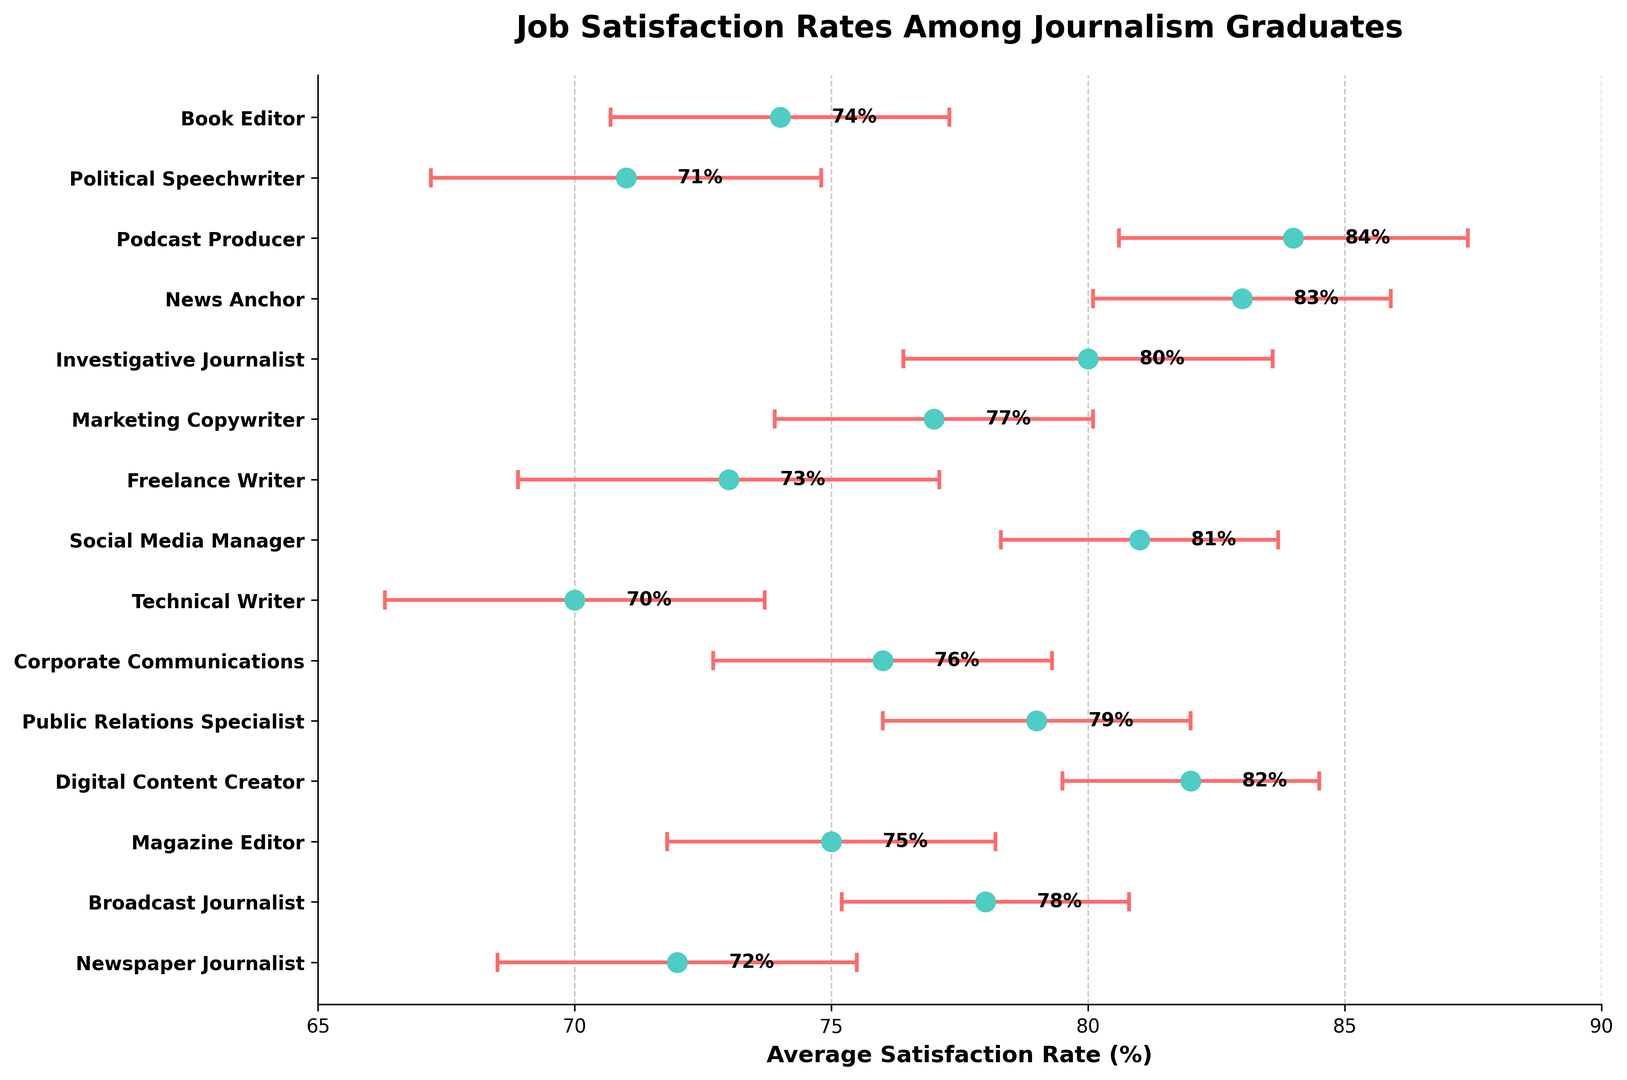Which career path has the highest job satisfaction rate? The plotted figure shows different career paths and their associated satisfaction rates. By visually identifying the highest point on the x-axis, we see that the Podcast Producer has the highest satisfaction rate, as represented by '84%'.
Answer: Podcast Producer Which career path has the lowest job satisfaction rate? By looking for the smallest point on the x-axis in the figure, we find that the Technical Writer has the lowest satisfaction rate at '70%'.
Answer: Technical Writer How does the job satisfaction rate of Public Relations Specialists compare to that of Investigative Journalists? Public Relations Specialists have a satisfaction rate of 79%, whereas Investigative Journalists have a satisfaction rate of 80%. Thus, Investigative Journalists have a slightly higher satisfaction rate.
Answer: Investigative Journalists Which career paths have a satisfaction rate above 80%? From the figure, we can identify the career paths with satisfaction rates higher than 80%. These are Digital Content Creator (82%), Social Media Manager (81%), News Anchor (83%), Podcast Producer (84%), and Investigative Journalist (80%).
Answer: Digital Content Creator, Social Media Manager, News Anchor, Podcast Producer, Investigative Journalist What is the difference in job satisfaction rate between a Magazine Editor and a Book Editor? The satisfaction rate for a Magazine Editor is 75%, and for a Book Editor, it is 74%. The difference between the two is calculated as 75% - 74% = 1%.
Answer: 1% Which career path has the largest margin of error? By examining the error bars visually, the Freelance Writer has the largest margin of error, which is 4.1%.
Answer: Freelance Writer How many career paths have a margin of error of at least 3%? To answer this, we count the number of career paths with error bars extending 3% or more. These career paths are Newspaper Journalist (3.5%), Broadcast Journalist (2.8%), Magazine Editor (3.2%), Public Relations Specialist (3.0%), Corporate Communications (3.3%), Technical Writer (3.7%), Investigative Journalist (3.6%), and Freelance Writer (4.1%), Political Speechwriter (3.8%), Book Editor (3.3%). Thus, ten career paths meet this criterion.
Answer: 10 What is the average job satisfaction rate across all the given career paths? We sum up all the satisfaction rates and divide by the total number of career paths. (72 + 78 + 75 + 82 + 79 + 76 + 70 + 81 + 73 + 77 + 80 + 83 + 84 + 71 + 74) / 15 = 1185 / 15 = 79%
Answer: 79% What is the combined error margin range for a Social Media Manager? The satisfaction rate for a Social Media Manager is 81% with a margin of error of 2.7%. Therefore, the error range is calculated as 81% ± 2.7%, giving a range from 78.3% to 83.7%.
Answer: 78.3% - 83.7% Which career paths have a satisfaction rate within one margin of error of 75%? The task is to identify career paths whose satisfaction rate, within their error margin, intersects 75%. Magazine Editor (75%, ±3.2%), Corporate Communications (76%, ±3.3%), and Book Editor (74%, ±3.3%) have ranges overlapping with 75% (71.8%-78.2%, 72.7%-79.3%, and 70.7%-77.3%).
Answer: Magazine Editor, Corporate Communications, Book Editor 